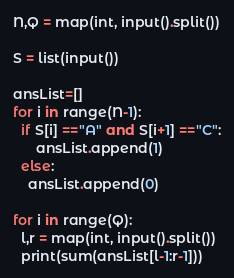<code> <loc_0><loc_0><loc_500><loc_500><_Python_>N,Q = map(int, input().split())

S = list(input())

ansList=[]
for i in range(N-1):
  if S[i] =="A" and S[i+1] =="C":
      ansList.append(1)
  else:
    ansList.append(0)

for i in range(Q):
  l,r = map(int, input().split())
  print(sum(ansList[l-1:r-1]))
</code> 